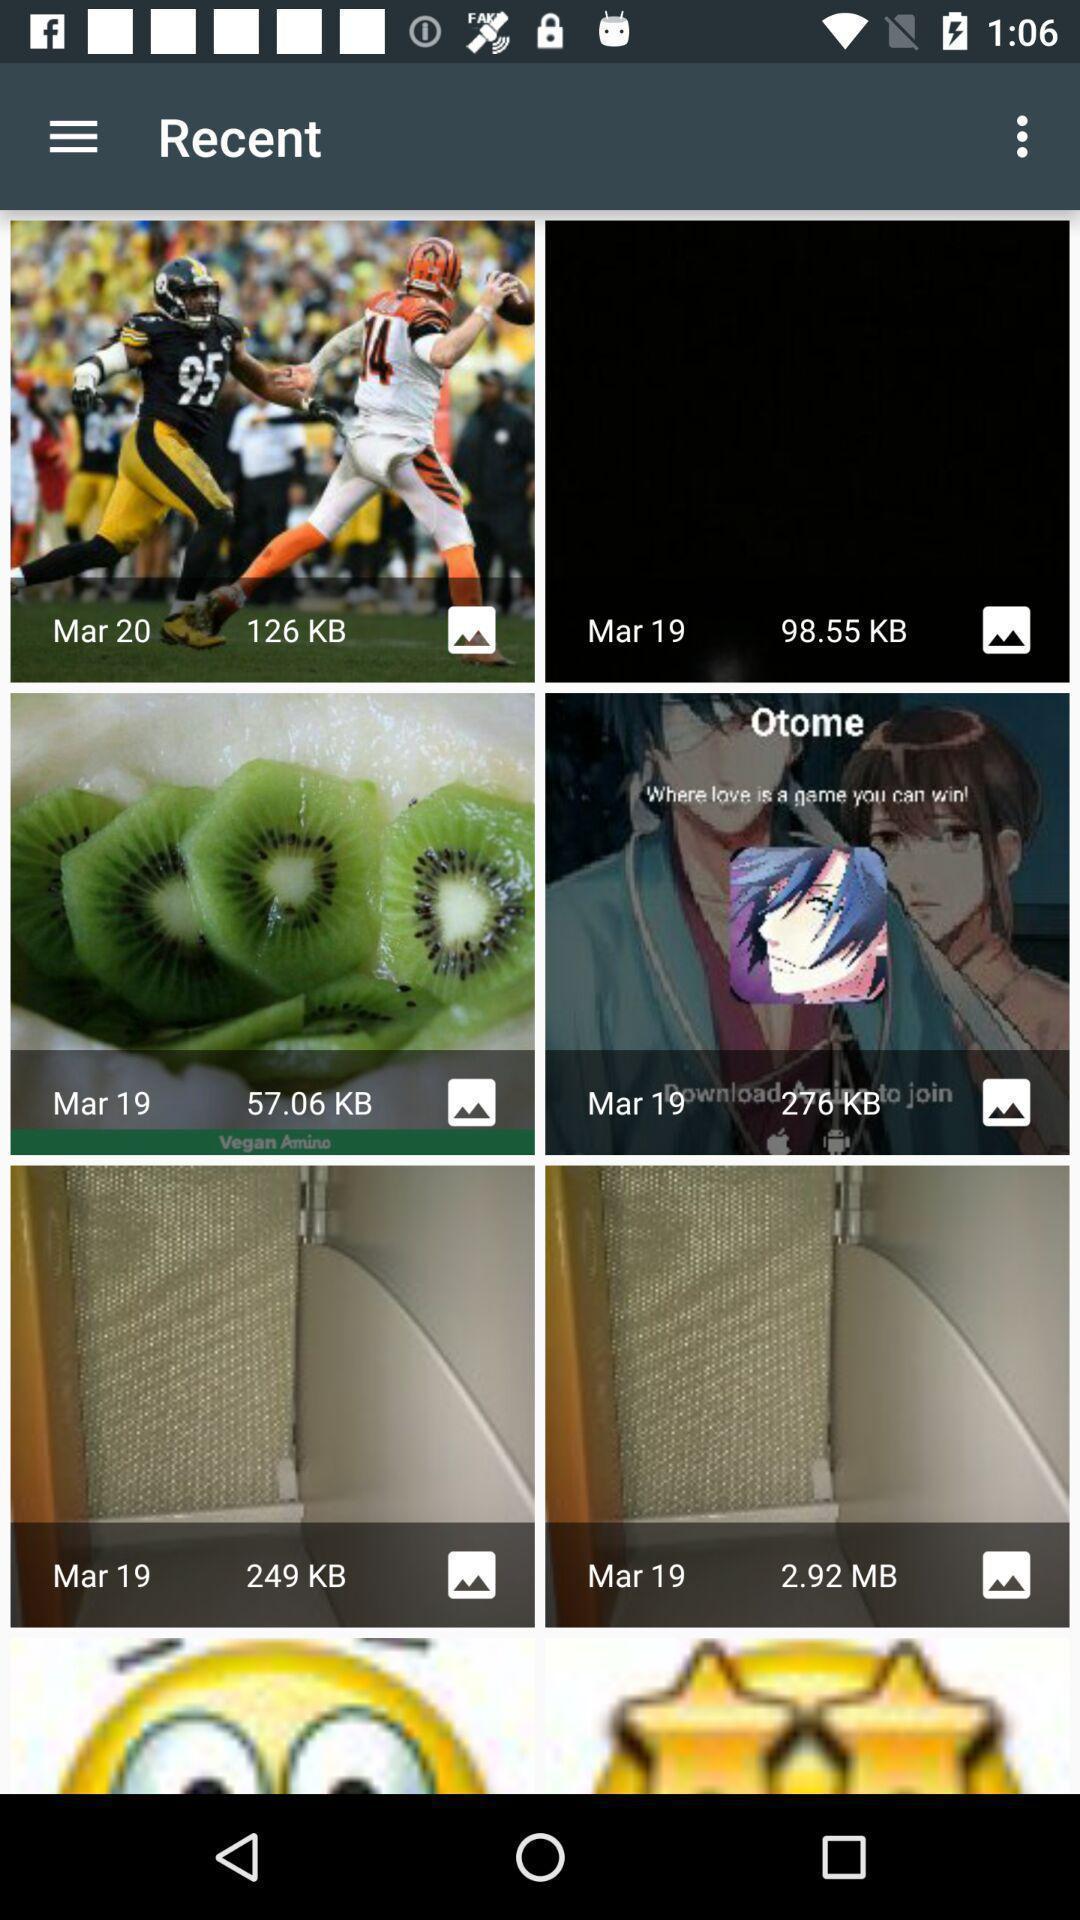Summarize the information in this screenshot. Screen displaying recent images page. 